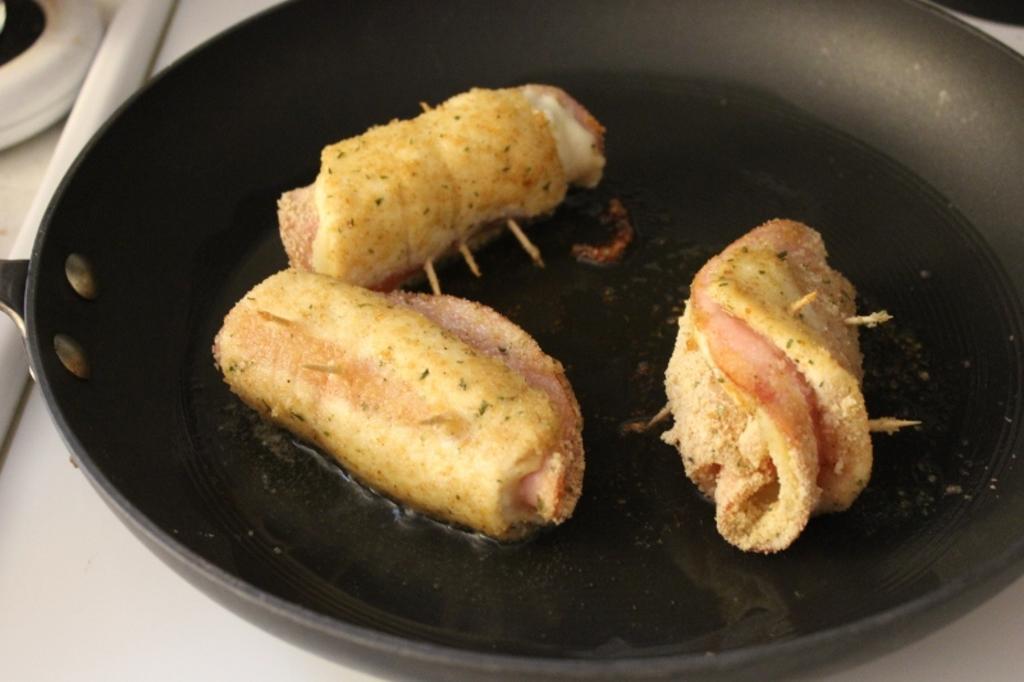How would you summarize this image in a sentence or two? In this image there is a stove with a pan on it. In the pan there is a food item. 